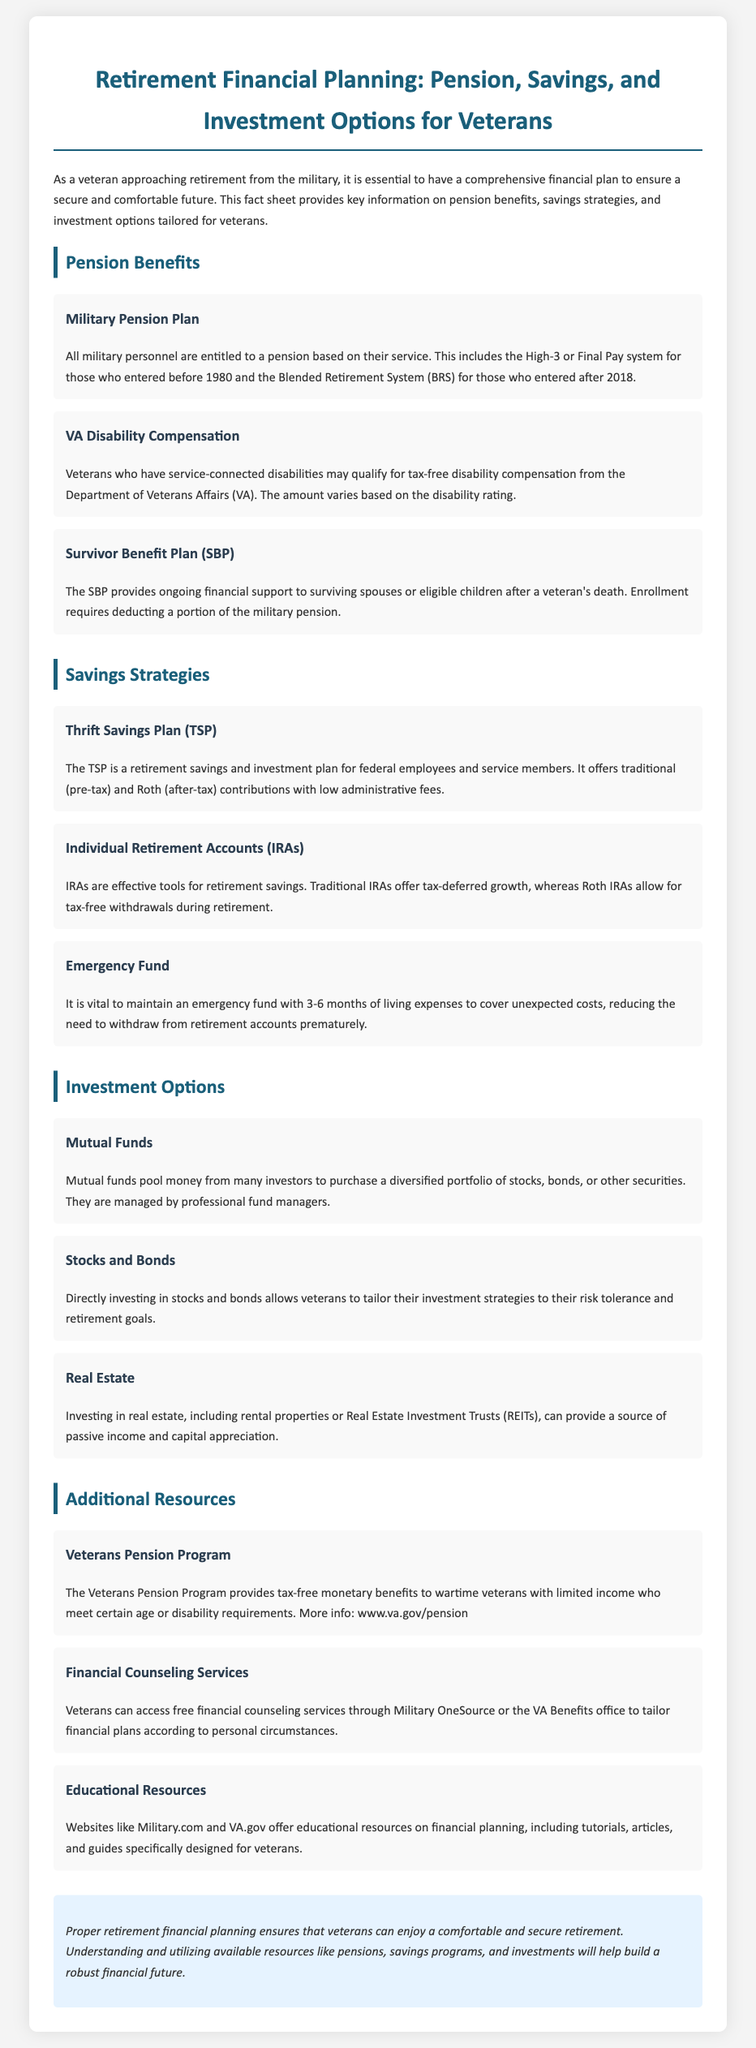What retirement savings plan is available for federal employees? This information can be found under the "Savings Strategies" section, stating that the TSP is a retirement savings and investment plan for federal employees and service members.
Answer: Thrift Savings Plan (TSP) How is the amount of VA Disability Compensation determined? The document explains that the amount varies based on the disability rating, which is critical information related to VA Disability Compensation.
Answer: Disability rating What does the Survivor Benefit Plan provide? The content item under "Pension Benefits" specifies that the SBP provides ongoing financial support to surviving spouses or eligible children after a veteran's death.
Answer: Financial support What are the two types of contributions for the Thrift Savings Plan? The document mentions that the TSP offers traditional and Roth contributions.
Answer: Traditional and Roth contributions What is an important element of maintaining an emergency fund? The document highlights that having an emergency fund with 3-6 months of living expenses is vital to cover unexpected costs.
Answer: 3-6 months of living expenses What type of investment option allows for tailored strategies to fit risk tolerance? In the section on investment options, the document states that directly investing in stocks and bonds allows for tailored investment strategies.
Answer: Stocks and bonds Which program provides monetary benefits to wartime veterans? The document specifies that the Veterans Pension Program offers tax-free monetary benefits to qualified wartime veterans.
Answer: Veterans Pension Program Which resource offers free financial counseling services? The document mentions that veterans can access free financial counseling services through Military OneSource or the VA Benefits office.
Answer: Military OneSource 